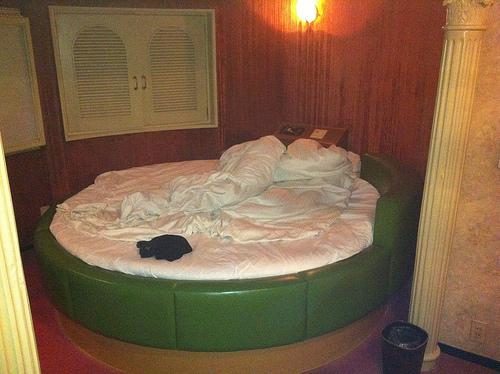Count the number of windows in the image. There are two windows. Name the color and type of the carpet in the image. The carpet in the image is dark maroon. What is the color and material of the bed in the image? The bed is green and brown, and it is made of leather. Estimate the overall emotions evoked by the image. The image evokes feelings of warmth, comfort, and relaxation. Identify an object in the image that serves a functional purpose and describe what it does. The rotational electric bed control device allows the bed to rotate for easy access and movement. Provide a brief analysis of the interaction between the person sleeping and the bed. The person sleeping is lying on the round bed with white sheets, enjoying the comfort and support provided by the bed. Provide a brief description of the bed in the image. The bed is a green and brown round rotating bed with white sheets on top. Does the bed have purple and yellow striped sheets? The bed sheets in the image are white or beige, and there are no purple and yellow striped sheets mentioned in the given information, making the instruction misleading with wrong sheet colors and design. Describe the walls in the image. Brown wood paneled walls and mottled beige wallpaper Select one: Are the bed sheets a) white or b) patterned with flowers? a) white Can you see a blue wall with colorful paintings in the room? The walls in the image are brown wood-paneled walls and mottled beige wall paper, so a blue wall with colorful paintings does not exist in the image. What type of device can be found in the room? Rotational electric bed control device What is the material of the sideboard? Wood Is the cat on the bed white and fluffy? No, it's not mentioned in the image. What kind of sleeping arrangement is shown in the image? A person sleeping on a round rotational green leather bed with white sheets List the two types of ventilation in the image. White shutter window ventilations and mesh ventilations Are there any window shutters in the room? Yes, white window shutters What is the color of the walls in the outer room? Mottled beige Describe the type of room portrayed in the image. Small wooden room with round bed and white shutter windows Where is the light located in the image? Over the bed What can be found at the foot of the bed? A black cloth Match the following terms with their description from the image: A)Small notebook B) trash can C) garment at foot of bed A) small notebook; B) black trash can; C) black cloth Is the pillar cream-colored or white? Cream-colored What color is the cat in the image? Black Is there a tall red pillar in the middle of the room? There are two cream-colored columns on the left and right sides of the room, and no red pillar in the middle of the room, making the instruction misleading with wrong pillar color and location. Is there an orange trash can on the right side of the bed? The image contains a black trash can, not an orange one, and it is not mentioned to be next to the bed, making the instruction misleading with incorrect color and location. Based on the image, describe the bed. Green and brown round rotating bed What is the function of handle of a side wall? Improving grip and ease of opening for shutter windows in the room State whether the white shutters are closed or open. Closed Identify the color of the carpet. Dark maroon Are there two pink round rotating beds in the room? The image contains only one round bed described as green and brown, not two, and they are not pink, making the instruction misleading with the wrong number and color of beds. Does this image contain a white sheet, a black trash can, or both? Both In the image, what is the significance of the cream-colored columns on the left and right sides? They serve as decorative Roman design pillars separating the room of the bed. 